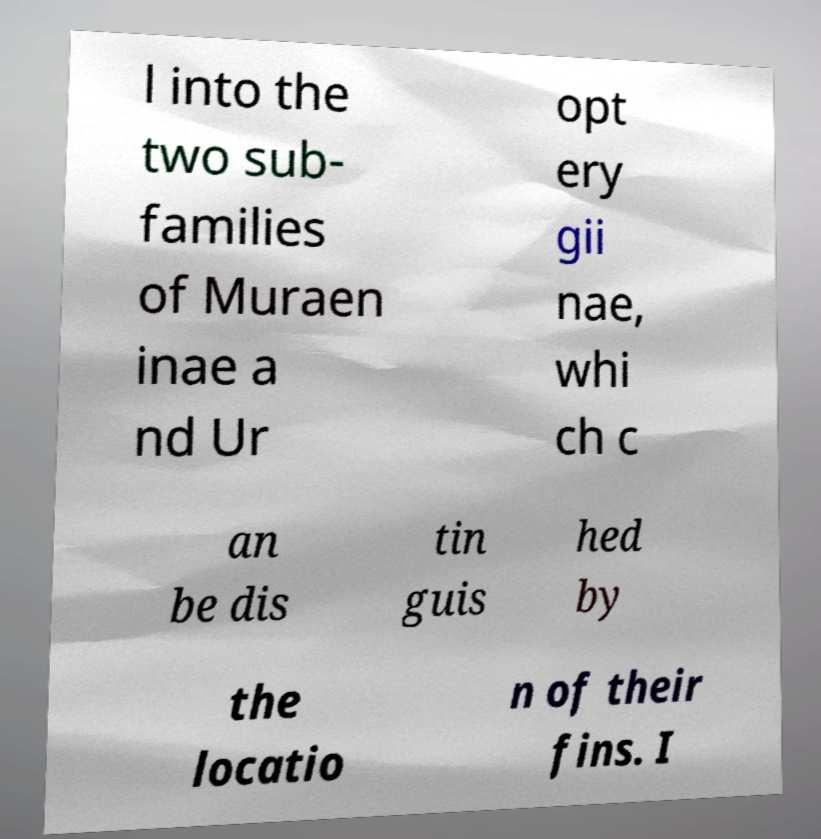I need the written content from this picture converted into text. Can you do that? l into the two sub- families of Muraen inae a nd Ur opt ery gii nae, whi ch c an be dis tin guis hed by the locatio n of their fins. I 